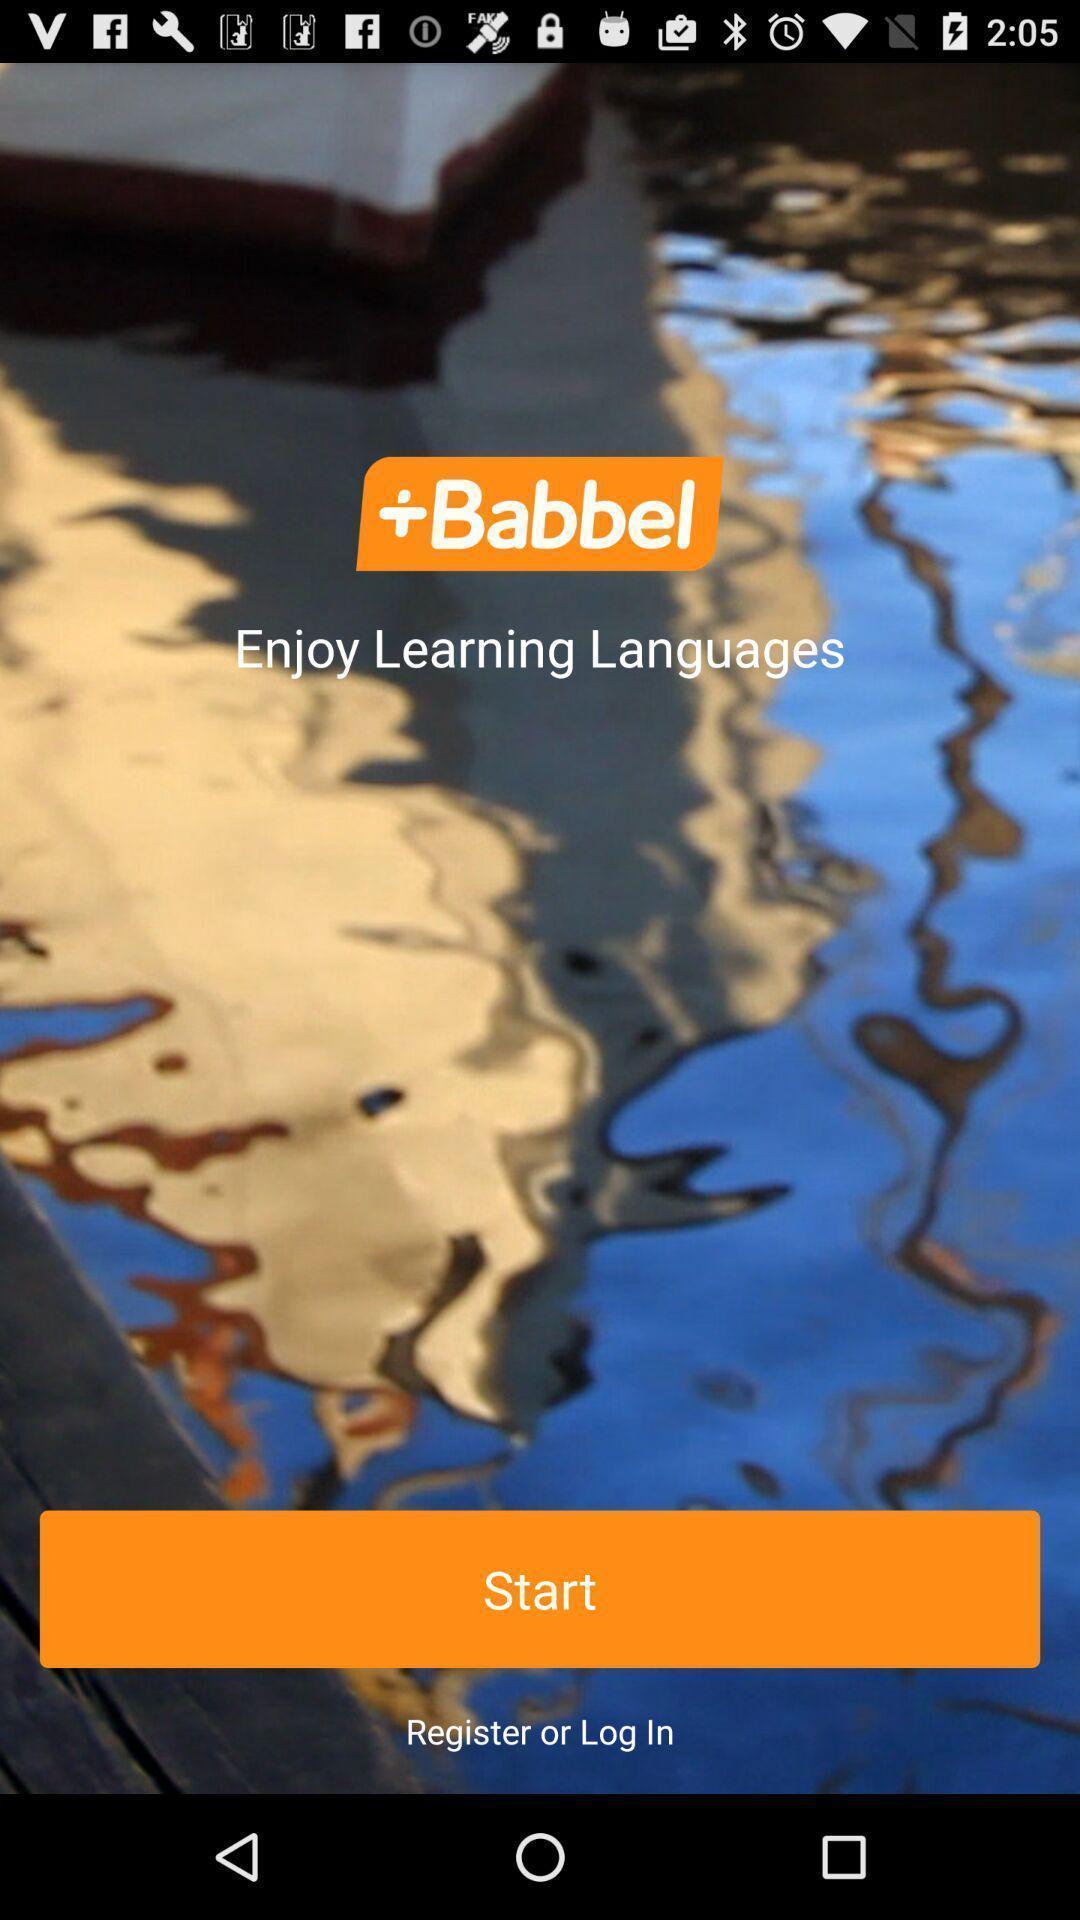Provide a textual representation of this image. Welcome page. 